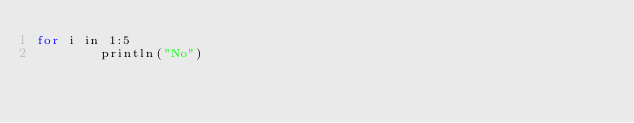Convert code to text. <code><loc_0><loc_0><loc_500><loc_500><_Julia_>for i in 1:5
        println("No")</code> 